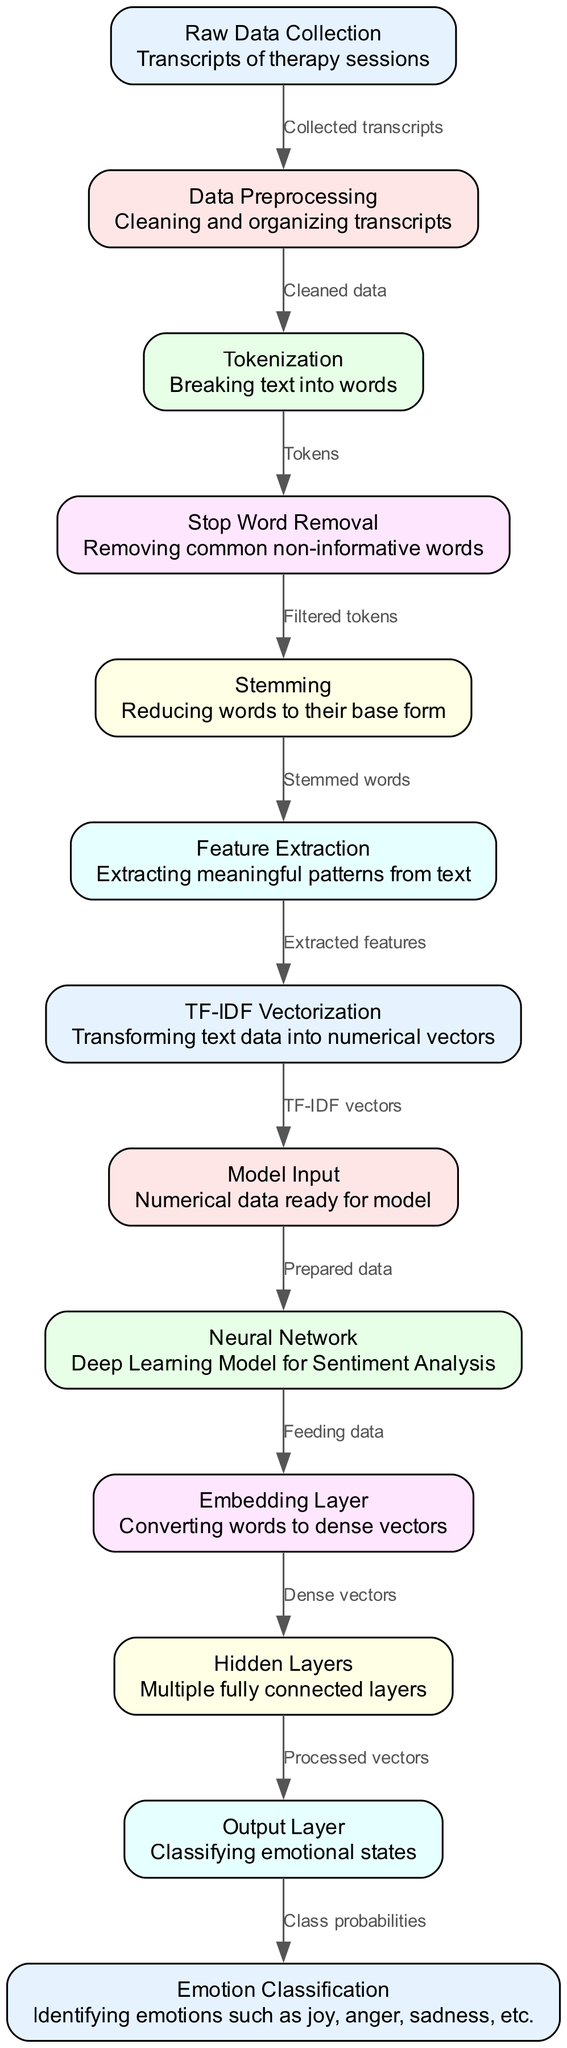What is the first node in the diagram? The diagram starts with the "Raw Data Collection" node, which is the first step in the process.
Answer: Raw Data Collection How many edges are present in the diagram? By counting the connections between nodes, there are 12 edges that connect various processes in the diagram.
Answer: 12 What is the output of the "Output Layer"? The "Output Layer" provides the class probabilities for different emotional states, determining how each state is classified.
Answer: Class probabilities What process comes after "Feature Extraction"? Following "Feature Extraction," the next step is "TF-IDF Vectorization," where extracted features are transformed into numerical vectors.
Answer: TF-IDF Vectorization Which node is responsible for removing non-informative words? The "Stop Word Removal" node is specifically designed to remove commonly occurring but non-informative words from the text.
Answer: Stop Word Removal What does the "Embedding Layer" convert? The "Embedding Layer" converts words into dense vectors, which helps in representing text in a format that the neural network can understand.
Answer: Dense vectors How does data flow from "Tokenization" to "Stemming"? After "Tokenization," the data is processed to "Stop Word Removal," and subsequently, from there, it moves to "Stemming," where words are reduced to their base form.
Answer: Through Filtered tokens What type of model is represented in the "Neural Network" node? The "Neural Network" is a deep learning model specifically designed for sentiment analysis, focusing on classifying emotional states based on input data.
Answer: Deep Learning Model for Sentiment Analysis Which node follows "Model Input"? The node that follows "Model Input" is the "Neural Network," where the prepared data is fed into the model for further processing.
Answer: Neural Network 